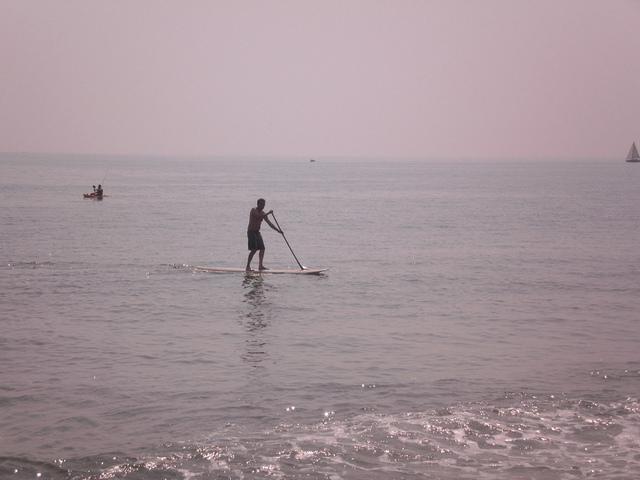Is there a woman on the beach?
Keep it brief. No. What are they doing?
Answer briefly. Paddling. Are there waves at this beach?
Give a very brief answer. No. Is the water cold?
Quick response, please. No. How many skiers are in the picture?
Write a very short answer. 0. What sport is being depicted?
Short answer required. Surfing. Is the man touching the water?
Be succinct. No. What kind of animals are flying above the person?
Short answer required. Birds. Are there waves?
Quick response, please. No. What is the person riding?
Write a very short answer. Surfboard. Are the waves big?
Give a very brief answer. No. What is the man holding on to?
Answer briefly. Paddle. Does the water appear calm or rough?
Concise answer only. Calm. What is the man doing?
Short answer required. Paddle boarding. Is this person in deep water?
Concise answer only. No. Is the water calm?
Keep it brief. Yes. What is this person holding?
Answer briefly. Paddle. What is he carrying on his hand?
Be succinct. Paddle. Is the sea blue?
Write a very short answer. No. What color is the water?
Write a very short answer. Blue. Is the wave traveling toward the surfer?
Concise answer only. No. Does this picture show calm waters?
Quick response, please. Yes. Is this women wearing skis?
Give a very brief answer. No. Is he wearing a wetsuit?
Answer briefly. No. What is on the man's feet?
Quick response, please. Nothing. What is the woman holding?
Keep it brief. Paddle. What color is the sky?
Concise answer only. Gray. What is the surfer wearing?
Concise answer only. Shorts. What is in the water?
Keep it brief. Surfer. Are there waves on the water?
Answer briefly. No. How many surfboards are there?
Quick response, please. 1. Is the sun out?
Keep it brief. No. How many oars are being used?
Answer briefly. 1. Is this person returning or going?
Be succinct. Returning. What motion is the water?
Write a very short answer. Still. Is the ocean water considered rough?
Write a very short answer. No. If the surfer were to stand, would the water be above his waist?
Write a very short answer. Yes. Is the person in the background wearing a hat?
Answer briefly. No. What is covering the ground?
Give a very brief answer. Water. Are there animals in the water?
Answer briefly. No. Is the surf big?
Be succinct. No. Is this by a lake?
Give a very brief answer. No. Is the person wearing a wetsuit?
Short answer required. No. What is behind the man on the water?
Keep it brief. Sailboat. What sport is this called?
Answer briefly. Paddle boarding. What is the man doing in the water?
Be succinct. Paddle boarding. Is the man wet?
Give a very brief answer. Yes. Is the boy going to use the object he is holding in the water?
Concise answer only. Yes. Is it low or high tide?
Be succinct. Low. 